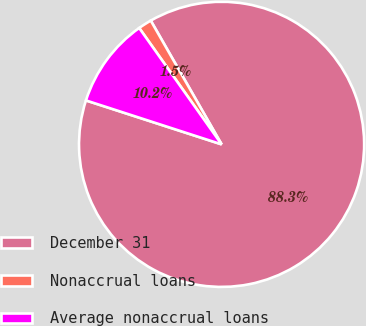Convert chart to OTSL. <chart><loc_0><loc_0><loc_500><loc_500><pie_chart><fcel>December 31<fcel>Nonaccrual loans<fcel>Average nonaccrual loans<nl><fcel>88.26%<fcel>1.53%<fcel>10.21%<nl></chart> 